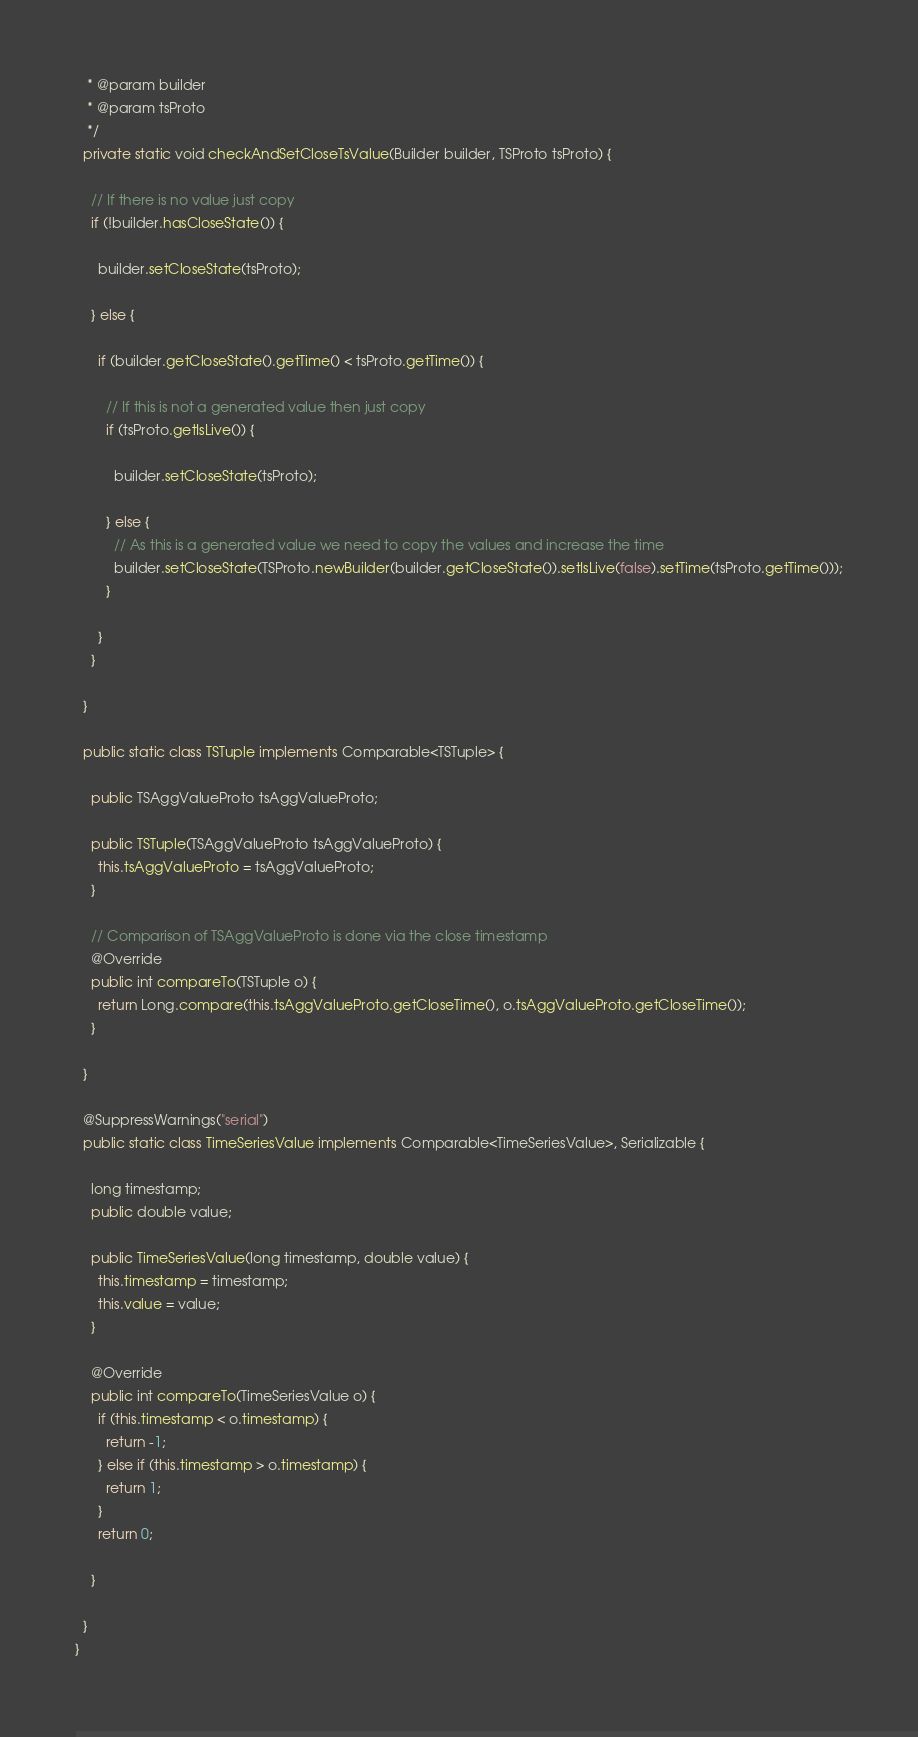<code> <loc_0><loc_0><loc_500><loc_500><_Java_>   * @param builder
   * @param tsProto
   */
  private static void checkAndSetCloseTsValue(Builder builder, TSProto tsProto) {

    // If there is no value just copy
    if (!builder.hasCloseState()) {

      builder.setCloseState(tsProto);

    } else {

      if (builder.getCloseState().getTime() < tsProto.getTime()) {
        
        // If this is not a generated value then just copy
        if (tsProto.getIsLive()) {
          
          builder.setCloseState(tsProto);
        
        } else {
          // As this is a generated value we need to copy the values and increase the time
          builder.setCloseState(TSProto.newBuilder(builder.getCloseState()).setIsLive(false).setTime(tsProto.getTime()));
        }

      }
    }

  }

  public static class TSTuple implements Comparable<TSTuple> {

    public TSAggValueProto tsAggValueProto;

    public TSTuple(TSAggValueProto tsAggValueProto) {
      this.tsAggValueProto = tsAggValueProto;
    }

    // Comparison of TSAggValueProto is done via the close timestamp
    @Override
    public int compareTo(TSTuple o) {
      return Long.compare(this.tsAggValueProto.getCloseTime(), o.tsAggValueProto.getCloseTime());
    }

  }

  @SuppressWarnings("serial")
  public static class TimeSeriesValue implements Comparable<TimeSeriesValue>, Serializable {

    long timestamp;
    public double value;

    public TimeSeriesValue(long timestamp, double value) {
      this.timestamp = timestamp;
      this.value = value;
    }

    @Override
    public int compareTo(TimeSeriesValue o) {
      if (this.timestamp < o.timestamp) {
        return -1;
      } else if (this.timestamp > o.timestamp) {
        return 1;
      }
      return 0;

    }

  }
}
</code> 